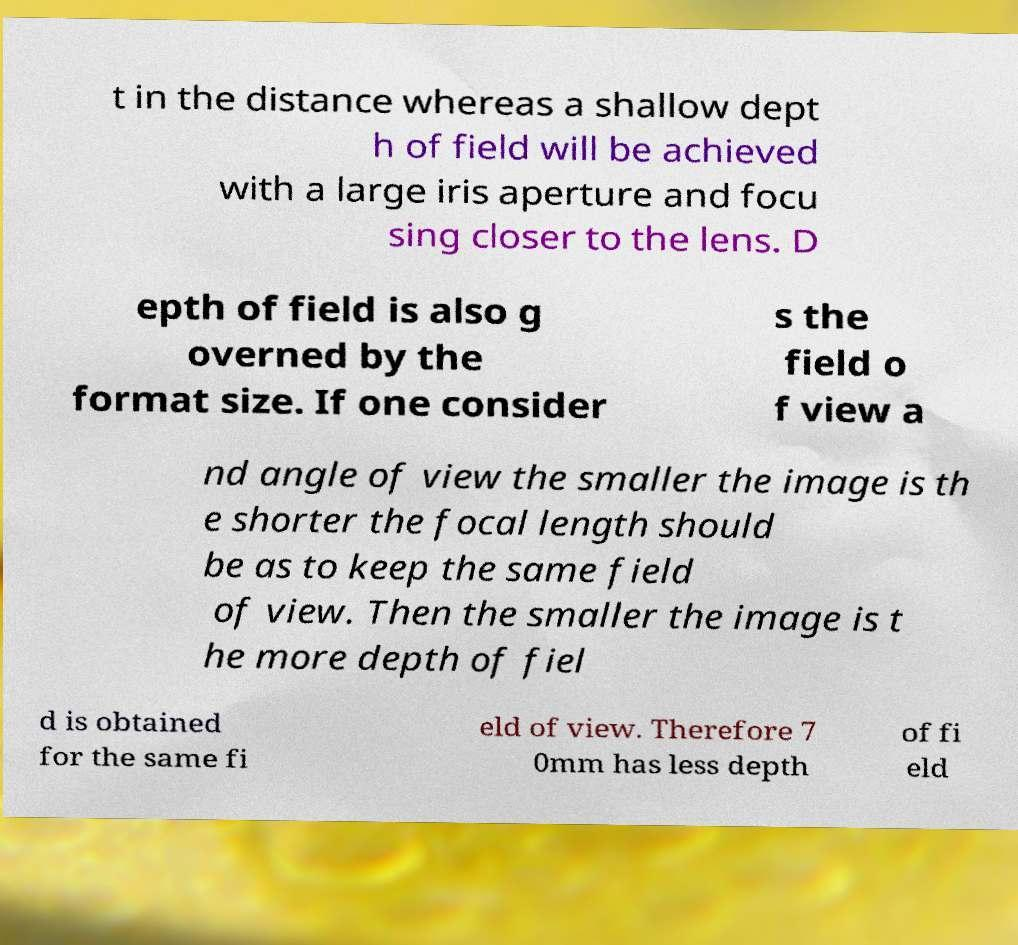I need the written content from this picture converted into text. Can you do that? t in the distance whereas a shallow dept h of field will be achieved with a large iris aperture and focu sing closer to the lens. D epth of field is also g overned by the format size. If one consider s the field o f view a nd angle of view the smaller the image is th e shorter the focal length should be as to keep the same field of view. Then the smaller the image is t he more depth of fiel d is obtained for the same fi eld of view. Therefore 7 0mm has less depth of fi eld 